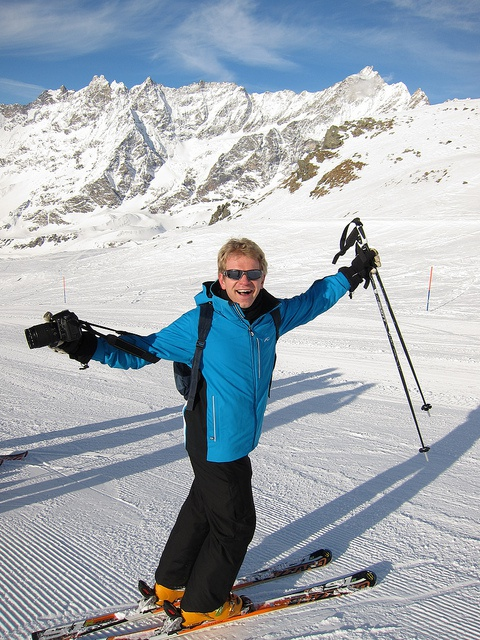Describe the objects in this image and their specific colors. I can see people in gray, black, and teal tones and backpack in gray, black, navy, and blue tones in this image. 